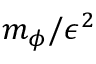<formula> <loc_0><loc_0><loc_500><loc_500>m _ { \phi } / \epsilon ^ { 2 }</formula> 